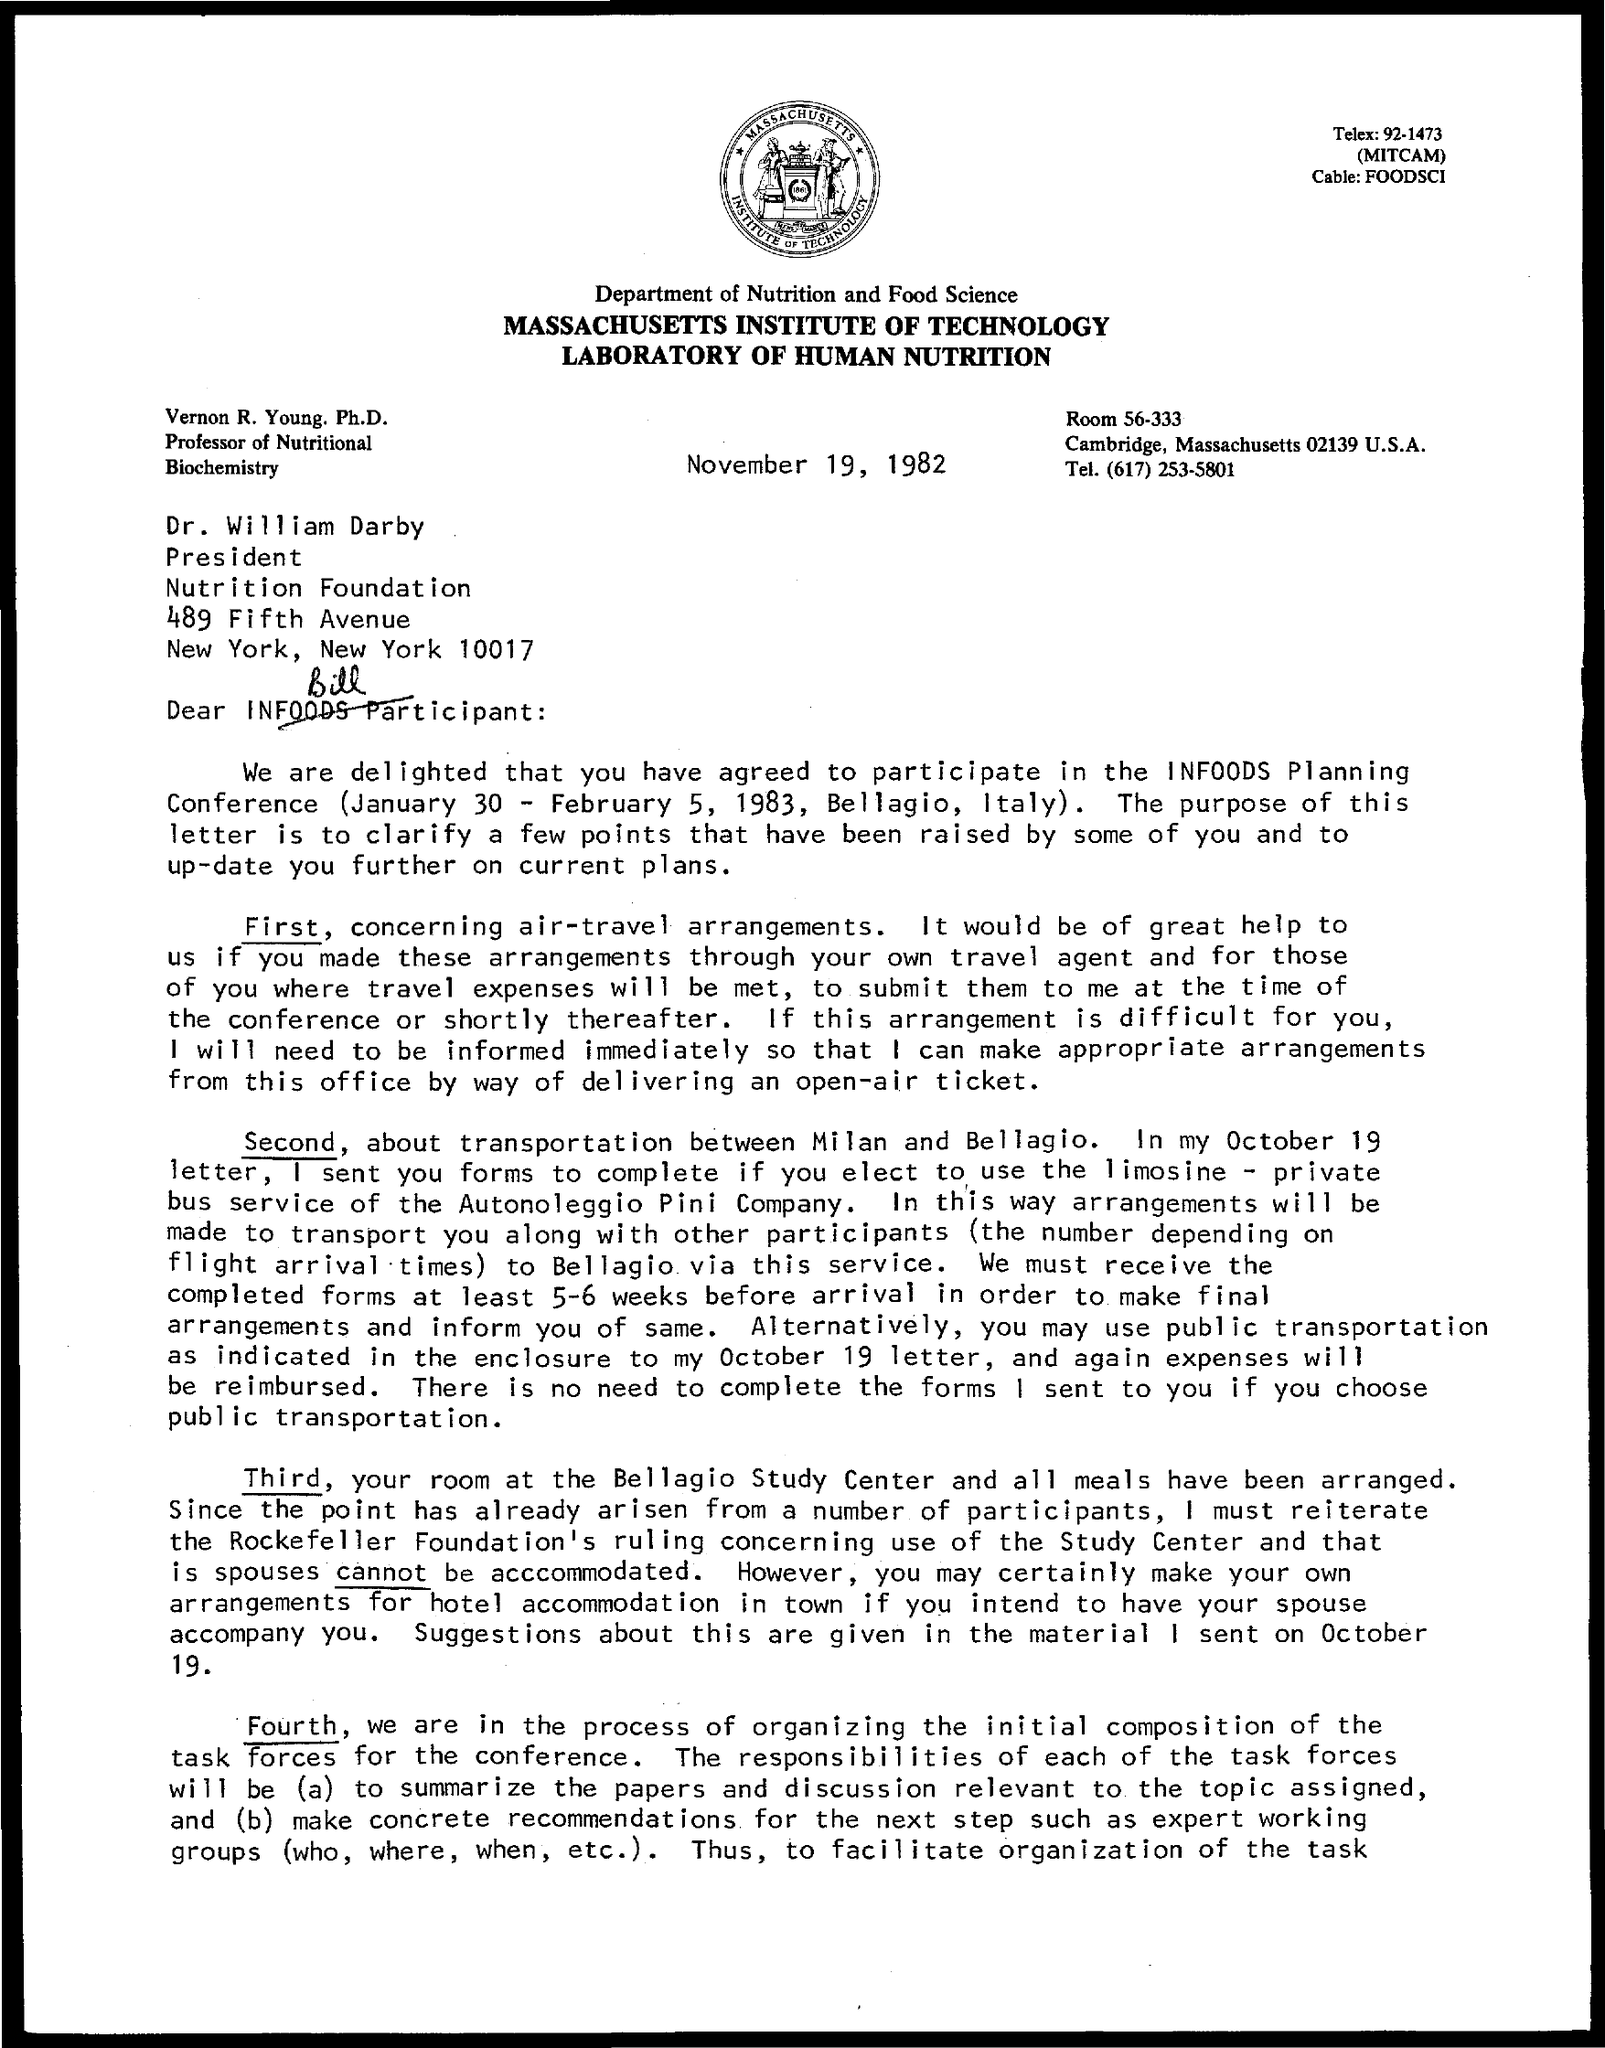What is the telephone number mentioned ?
Give a very brief answer. (617) 253-5801. Who is the president of nutrition president
Provide a short and direct response. Dr. william Darby. In which city nutrition foundation located
Provide a short and direct response. New york. What is the room no mentioned
Your answer should be compact. 56-333. 